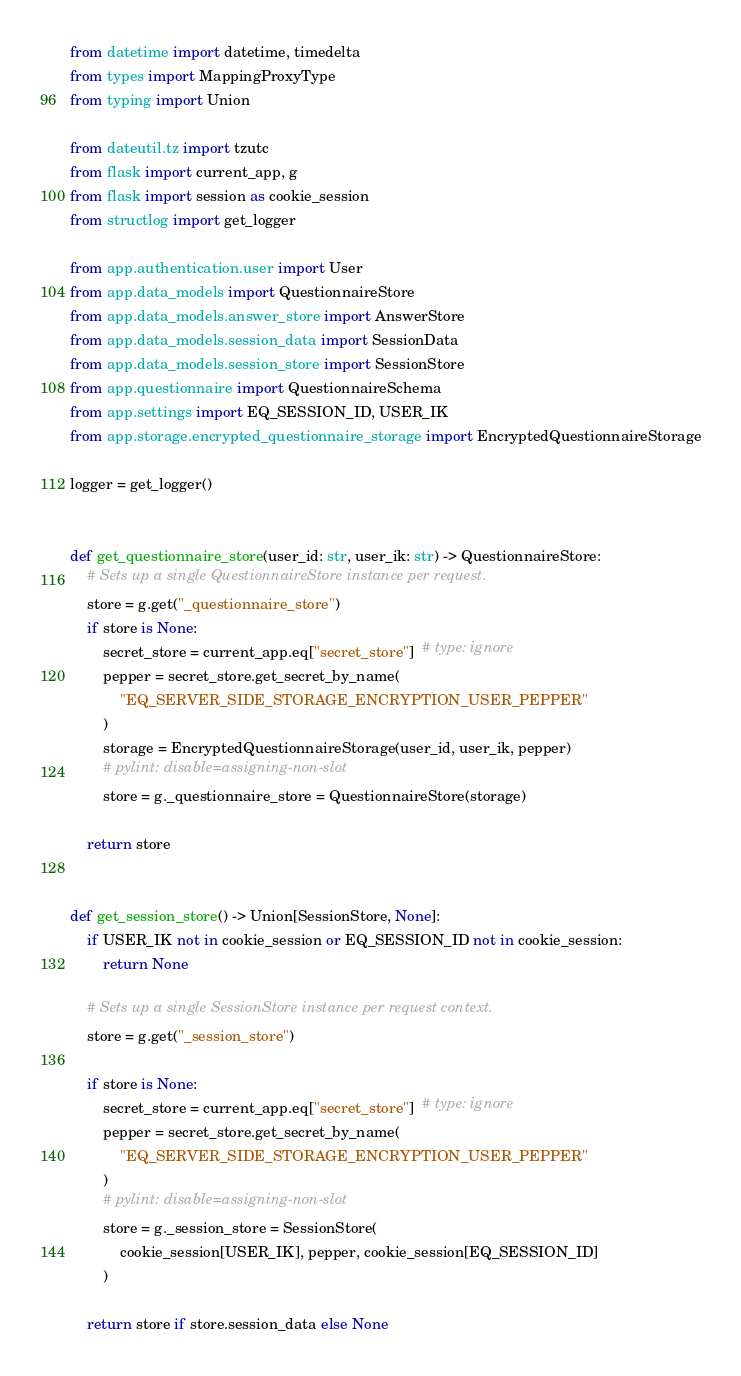Convert code to text. <code><loc_0><loc_0><loc_500><loc_500><_Python_>from datetime import datetime, timedelta
from types import MappingProxyType
from typing import Union

from dateutil.tz import tzutc
from flask import current_app, g
from flask import session as cookie_session
from structlog import get_logger

from app.authentication.user import User
from app.data_models import QuestionnaireStore
from app.data_models.answer_store import AnswerStore
from app.data_models.session_data import SessionData
from app.data_models.session_store import SessionStore
from app.questionnaire import QuestionnaireSchema
from app.settings import EQ_SESSION_ID, USER_IK
from app.storage.encrypted_questionnaire_storage import EncryptedQuestionnaireStorage

logger = get_logger()


def get_questionnaire_store(user_id: str, user_ik: str) -> QuestionnaireStore:
    # Sets up a single QuestionnaireStore instance per request.
    store = g.get("_questionnaire_store")
    if store is None:
        secret_store = current_app.eq["secret_store"]  # type: ignore
        pepper = secret_store.get_secret_by_name(
            "EQ_SERVER_SIDE_STORAGE_ENCRYPTION_USER_PEPPER"
        )
        storage = EncryptedQuestionnaireStorage(user_id, user_ik, pepper)
        # pylint: disable=assigning-non-slot
        store = g._questionnaire_store = QuestionnaireStore(storage)

    return store


def get_session_store() -> Union[SessionStore, None]:
    if USER_IK not in cookie_session or EQ_SESSION_ID not in cookie_session:
        return None

    # Sets up a single SessionStore instance per request context.
    store = g.get("_session_store")

    if store is None:
        secret_store = current_app.eq["secret_store"]  # type: ignore
        pepper = secret_store.get_secret_by_name(
            "EQ_SERVER_SIDE_STORAGE_ENCRYPTION_USER_PEPPER"
        )
        # pylint: disable=assigning-non-slot
        store = g._session_store = SessionStore(
            cookie_session[USER_IK], pepper, cookie_session[EQ_SESSION_ID]
        )

    return store if store.session_data else None

</code> 